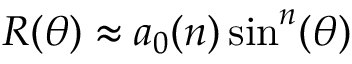<formula> <loc_0><loc_0><loc_500><loc_500>R ( \theta ) \approx a _ { 0 } ( n ) \sin ^ { n } ( \theta )</formula> 